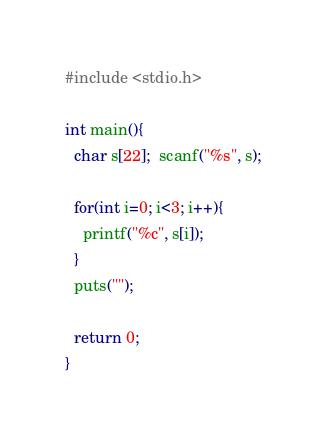Convert code to text. <code><loc_0><loc_0><loc_500><loc_500><_C_>#include <stdio.h>

int main(){
  char s[22];  scanf("%s", s);
  
  for(int i=0; i<3; i++){
    printf("%c", s[i]);
  }
  puts("");
  
  return 0;
}</code> 